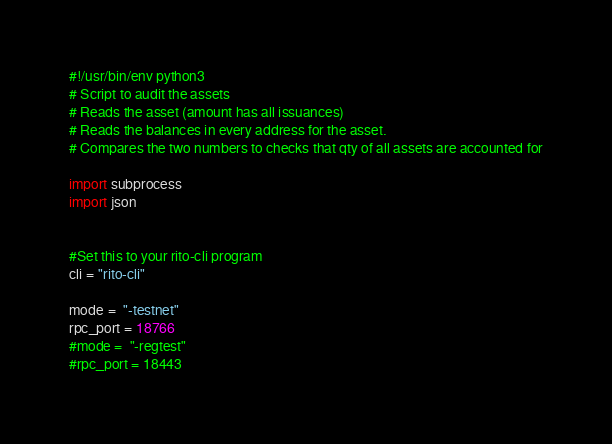Convert code to text. <code><loc_0><loc_0><loc_500><loc_500><_Python_>#!/usr/bin/env python3
# Script to audit the assets
# Reads the asset (amount has all issuances)
# Reads the balances in every address for the asset.
# Compares the two numbers to checks that qty of all assets are accounted for

import subprocess
import json


#Set this to your rito-cli program
cli = "rito-cli"

mode =  "-testnet"
rpc_port = 18766
#mode =  "-regtest"
#rpc_port = 18443
</code> 